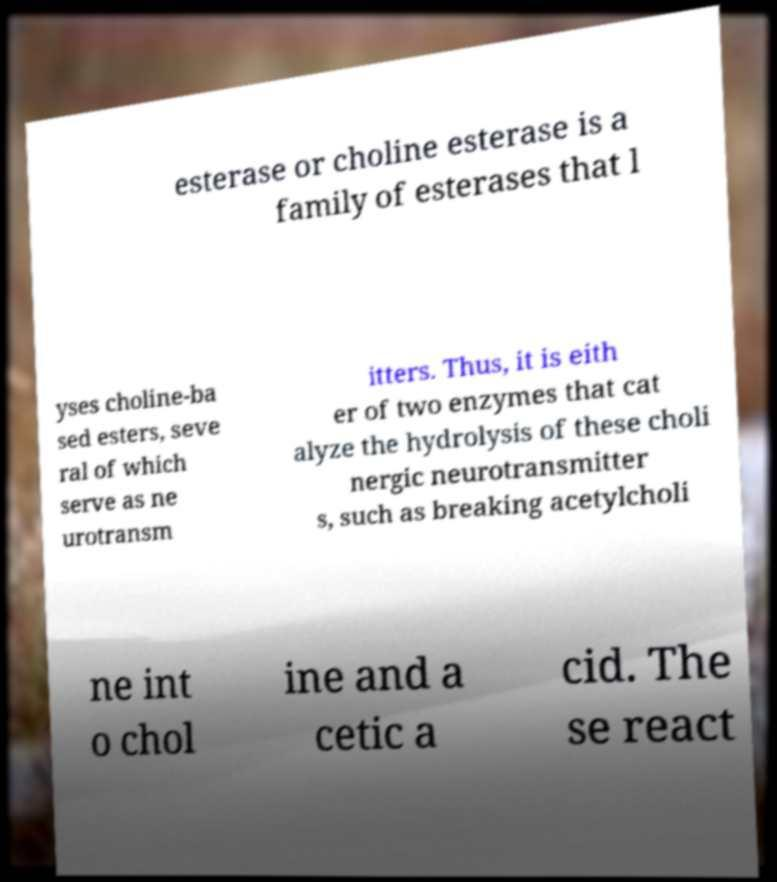Can you read and provide the text displayed in the image?This photo seems to have some interesting text. Can you extract and type it out for me? esterase or choline esterase is a family of esterases that l yses choline-ba sed esters, seve ral of which serve as ne urotransm itters. Thus, it is eith er of two enzymes that cat alyze the hydrolysis of these choli nergic neurotransmitter s, such as breaking acetylcholi ne int o chol ine and a cetic a cid. The se react 